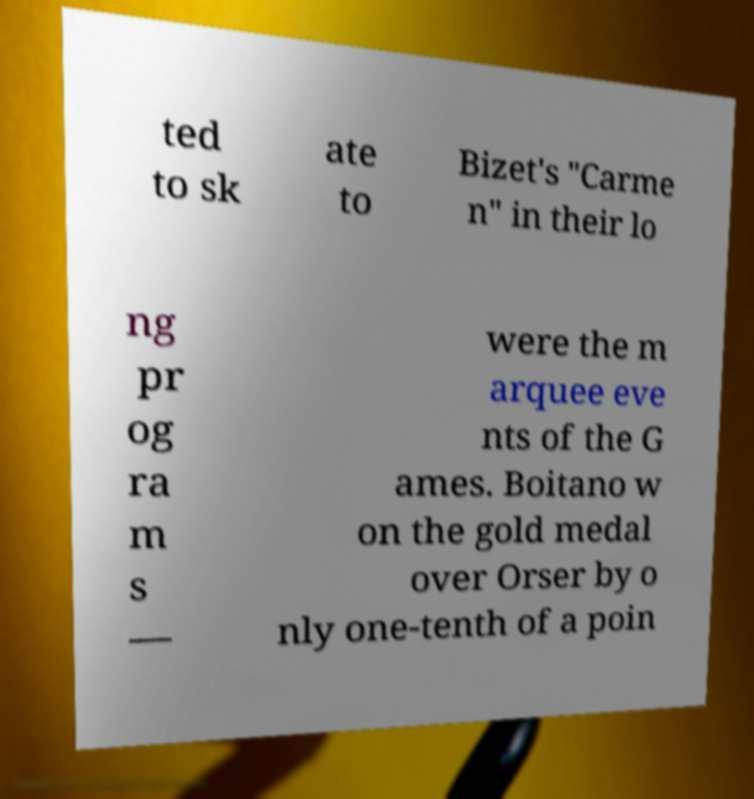There's text embedded in this image that I need extracted. Can you transcribe it verbatim? ted to sk ate to Bizet's "Carme n" in their lo ng pr og ra m s — were the m arquee eve nts of the G ames. Boitano w on the gold medal over Orser by o nly one-tenth of a poin 